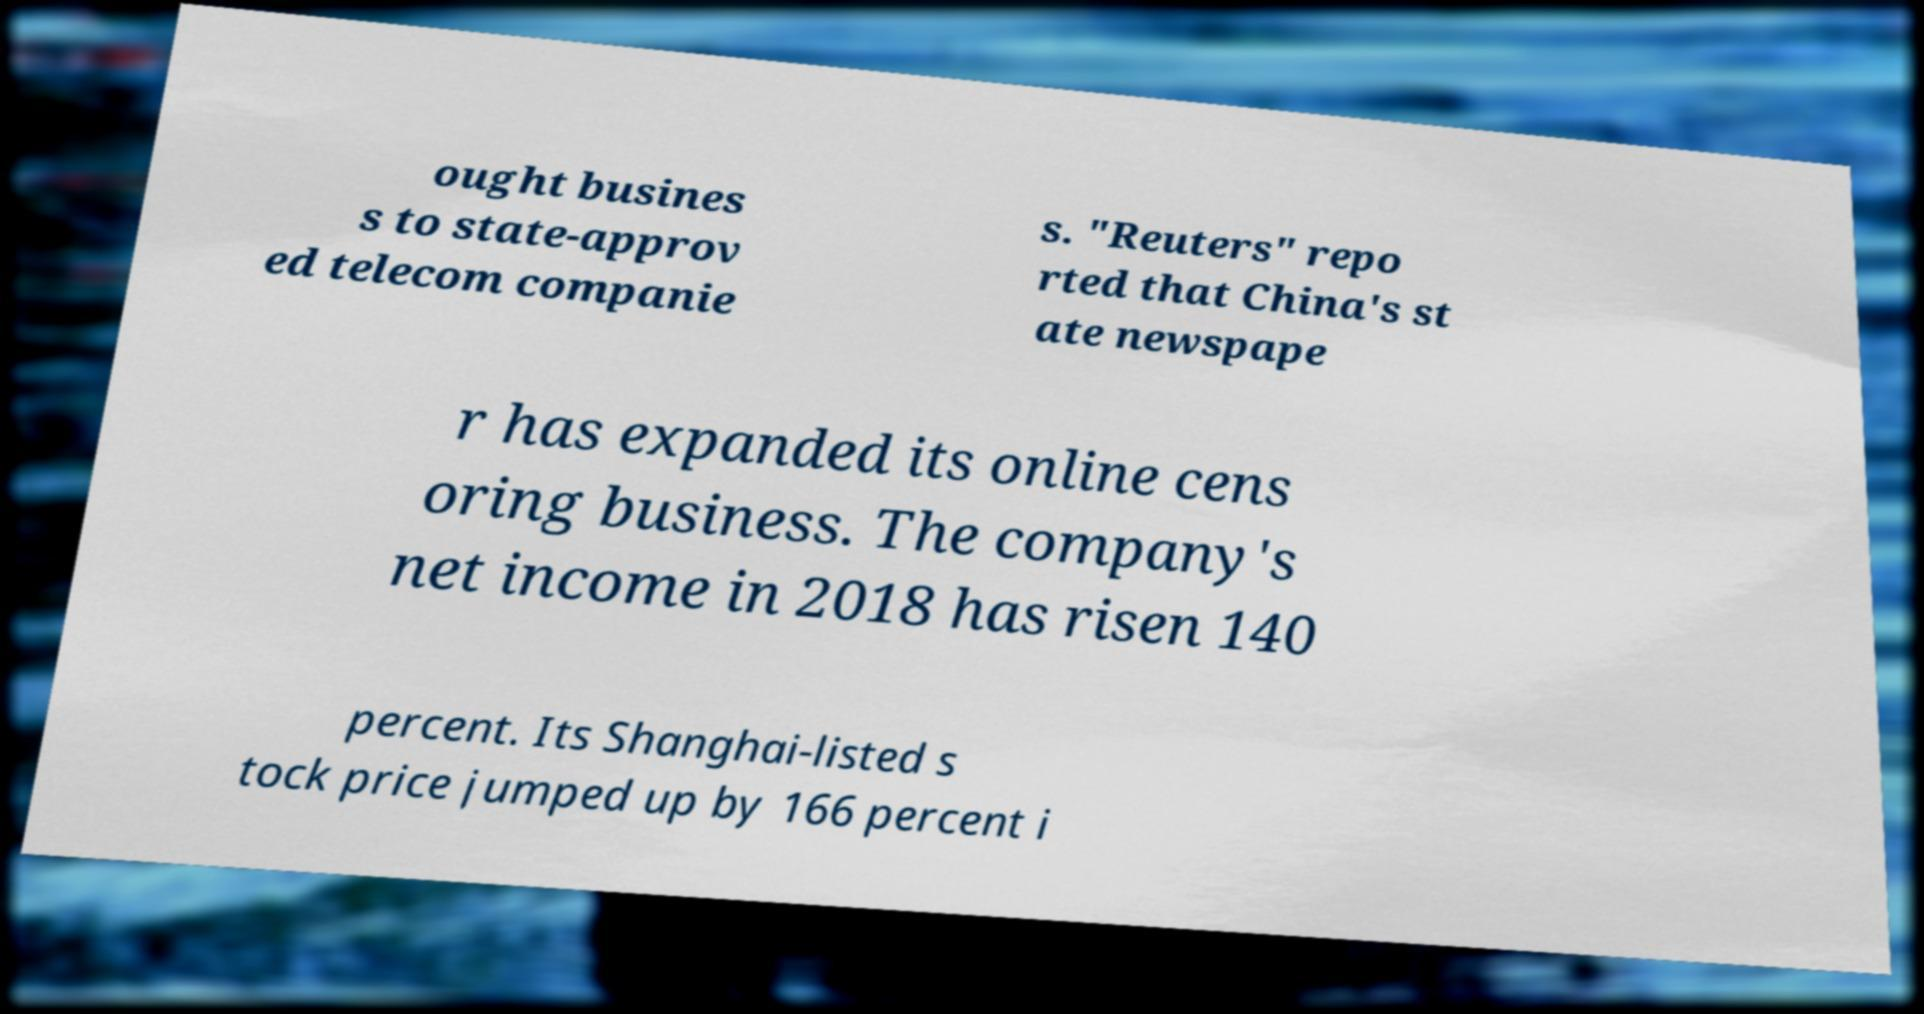Please read and relay the text visible in this image. What does it say? ought busines s to state-approv ed telecom companie s. "Reuters" repo rted that China's st ate newspape r has expanded its online cens oring business. The company's net income in 2018 has risen 140 percent. Its Shanghai-listed s tock price jumped up by 166 percent i 